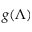<formula> <loc_0><loc_0><loc_500><loc_500>g ( \Lambda )</formula> 